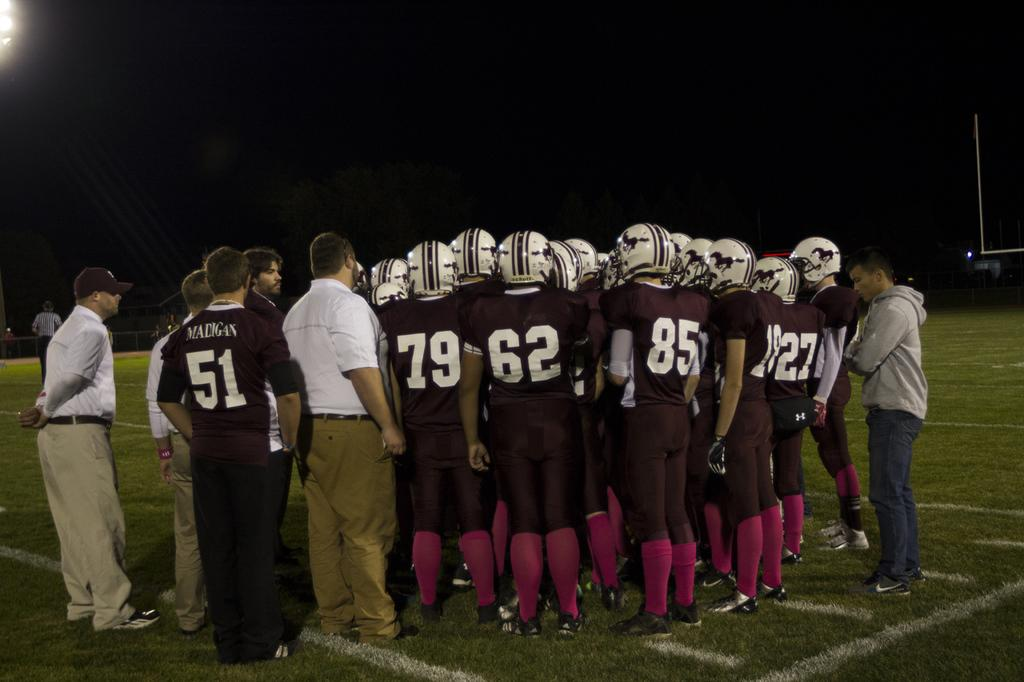How many people are in the image? There is a group of people in the image, but the exact number is not specified. What is the position of the people in the image? The people are standing on the ground in the image. What is visible at the top of the image? There is light at the top of the image. What can be observed about the background of the image? The background of the image is dark. What type of fork can be seen in the image? There is no fork present in the image. Is there a water tank visible in the image? There is no water tank present in the image. 